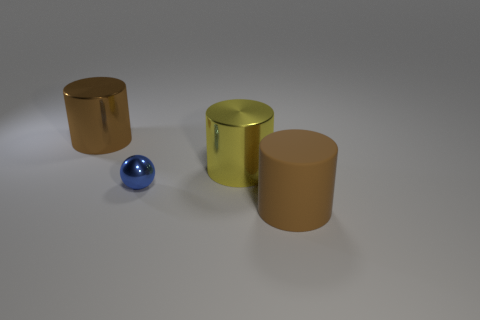Are there any other things that are the same size as the blue object?
Offer a terse response. No. Is there any other thing of the same color as the matte cylinder?
Make the answer very short. Yes. Is the number of yellow cylinders in front of the big matte cylinder less than the number of blue metallic objects?
Offer a very short reply. Yes. Is the number of blue objects greater than the number of tiny yellow objects?
Provide a short and direct response. Yes. There is a metal cylinder right of the brown cylinder on the left side of the brown rubber thing; is there a shiny thing in front of it?
Give a very brief answer. Yes. What number of other things are there of the same size as the shiny sphere?
Offer a very short reply. 0. Are there any brown things behind the matte thing?
Your response must be concise. Yes. Does the matte thing have the same color as the cylinder that is left of the small ball?
Offer a very short reply. Yes. What is the color of the cylinder that is right of the large metallic thing that is in front of the large brown cylinder that is behind the brown matte cylinder?
Make the answer very short. Brown. Are there any other big objects of the same shape as the brown matte thing?
Ensure brevity in your answer.  Yes. 